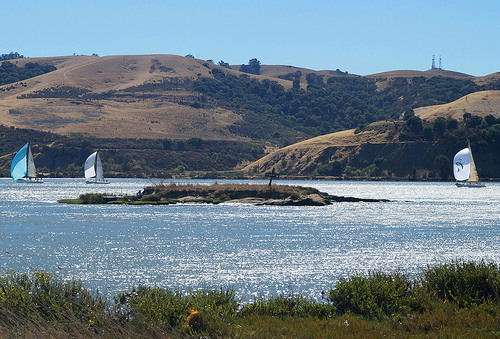<image>
Is there a ship above the water? No. The ship is not positioned above the water. The vertical arrangement shows a different relationship. 